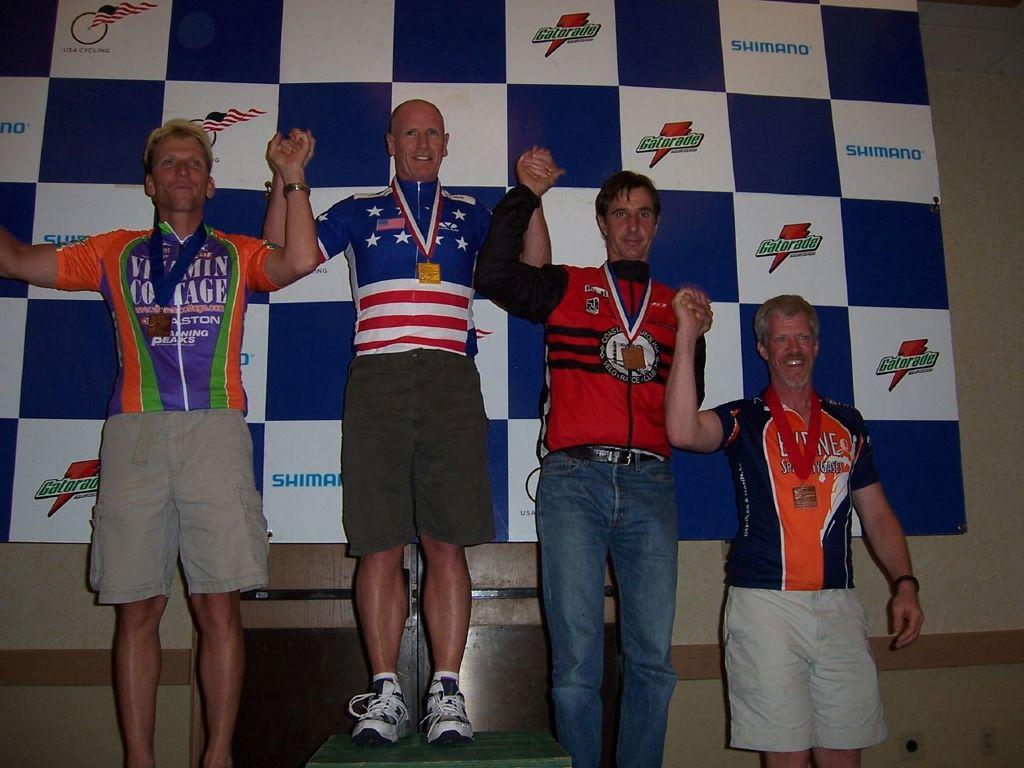<image>
Provide a brief description of the given image. A group of athletes wearing medals pose in front of a Gatorade banner. 